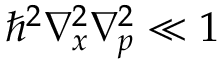Convert formula to latex. <formula><loc_0><loc_0><loc_500><loc_500>\hbar { ^ } { 2 } \nabla _ { x } ^ { 2 } \nabla _ { p } ^ { 2 } \ll 1</formula> 